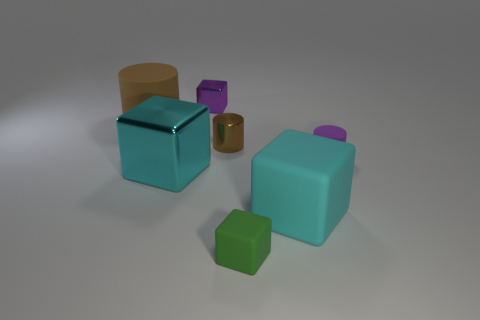There is a purple object behind the purple rubber cylinder; what number of rubber things are left of it?
Your answer should be compact. 1. How many large things are in front of the brown metal cylinder?
Give a very brief answer. 2. How many other objects are there of the same size as the green rubber cube?
Your response must be concise. 3. What size is the green thing that is the same shape as the purple metal object?
Provide a succinct answer. Small. What is the shape of the purple object that is in front of the big brown rubber cylinder?
Your answer should be very brief. Cylinder. There is a tiny cylinder left of the cyan rubber block that is behind the small green block; what color is it?
Your response must be concise. Brown. How many things are cylinders that are right of the green cube or large objects?
Offer a very short reply. 4. There is a purple block; does it have the same size as the metal cube in front of the tiny purple cylinder?
Provide a short and direct response. No. How many tiny things are brown metal cylinders or cylinders?
Provide a short and direct response. 2. There is a brown matte thing; what shape is it?
Make the answer very short. Cylinder. 